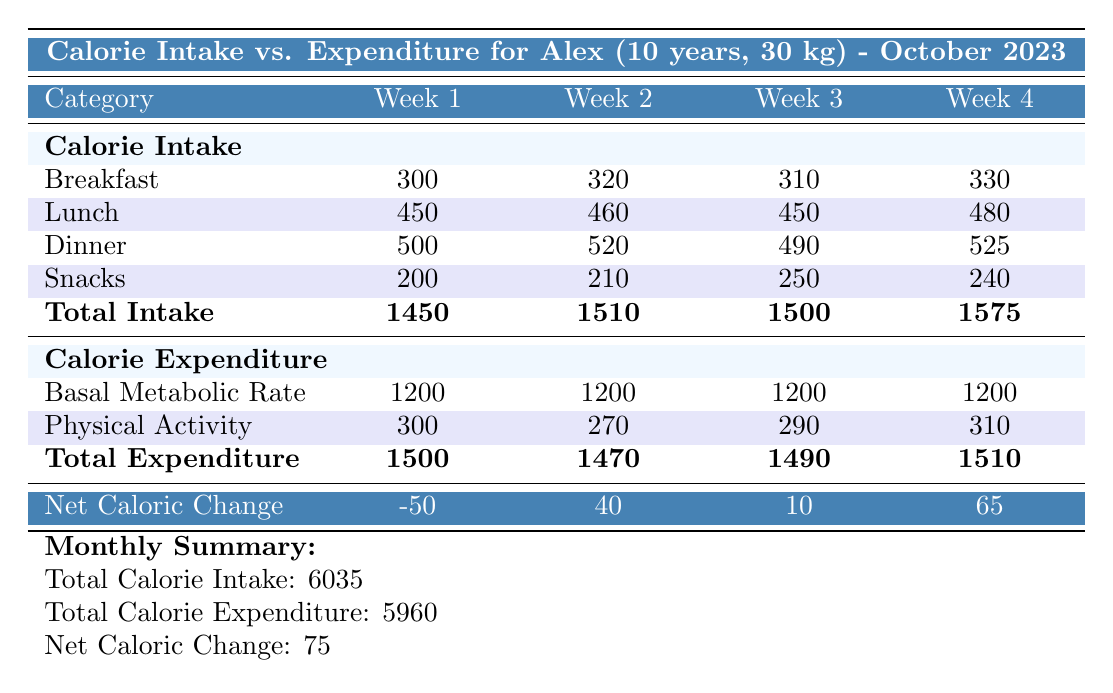What is the total calorie intake for week 1? The table shows the total calorie intake for week 1 listed under Total Intake, which is 1450.
Answer: 1450 What was Alex's total calorie expenditure for week 3? The total calorie expenditure for week 3 is found under Total Expenditure and is reported as 1490.
Answer: 1490 Did Alex's calorie intake increase or decrease from week 1 to week 2? To find out, we compare the Total Intake values for week 1 (1450) and week 2 (1510). Since 1510 > 1450, it increased.
Answer: Increased What was the net caloric change for week 4? The net caloric change for week 4 is noted on the last row labeled Net Caloric Change, and it states 65.
Answer: 65 What is the total calorie intake across all weeks? To find the total calorie intake, we sum the values for Total Intake: 1450 + 1510 + 1500 + 1575 = 6035.
Answer: 6035 What is the average calorie expenditure over the four weeks? The total calorie expenditure is calculated by summing the Total Expenditure values: 1500 + 1470 + 1490 + 1510 = 5980. Then, divide by the number of weeks, which is 4: 5980 / 4 = 1495.
Answer: 1495 Is the total calorie intake higher or lower than the total calorie expenditure for the month? We compare the Monthly Summary values: Total Calorie Intake (6035) is greater than Total Calorie Expenditure (5960). So, it is higher.
Answer: Higher Which week had the highest calorie intake and what was it? By reviewing the Total Intake values, week 4 has the highest intake of 1575.
Answer: 1575 What was the change in calorie expenditure from week 2 to week 4? We look at the Total Expenditure values for week 2 (1470) and week 4 (1510). The change is calculated as 1510 - 1470 = 40.
Answer: 40 What was the average daily calorie intake for Alex in October 2023? The total calorie intake for the month is 6035. To find the average daily intake: 6035 / 31 days (for October) = approximately 194.
Answer: 194 